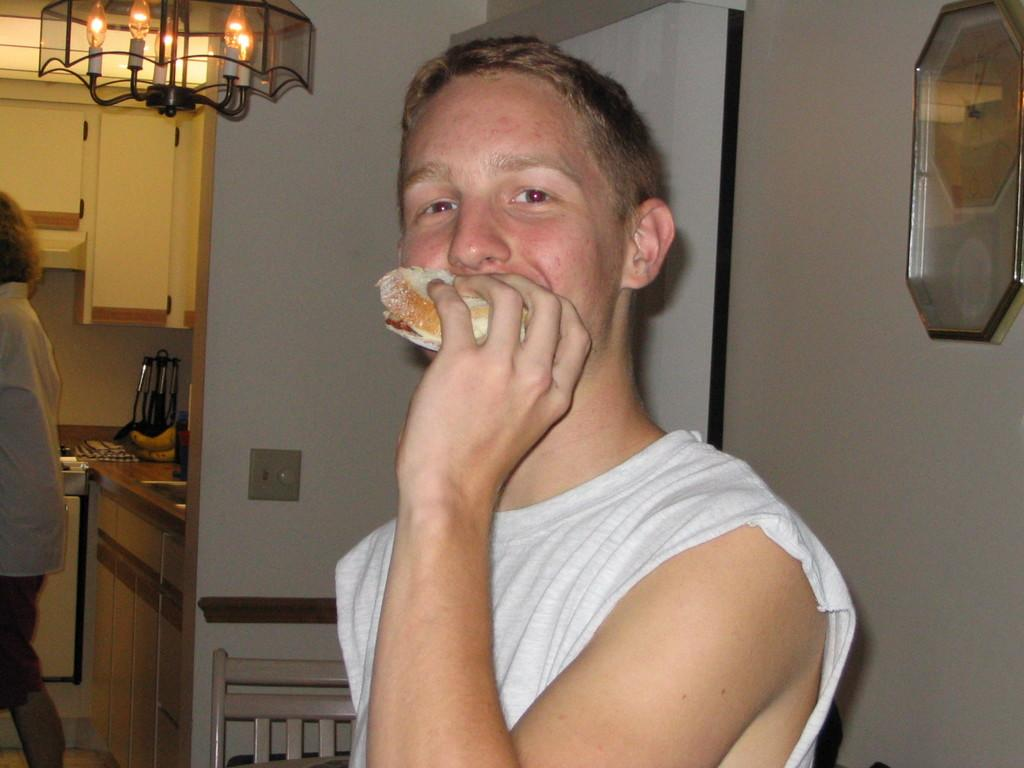What is the man in the image holding? The man is holding food in the image. What can be seen in the background of the image? There is a wall, a person, a kitchen platform, cupboards, and some objects in the background of the image. Can you describe the setting where the man is located? The man is in a kitchen, as evidenced by the kitchen platform and cupboards in the background. What type of poison is the man using to prepare the food in the image? There is no indication in the image that the man is using poison to prepare the food. 